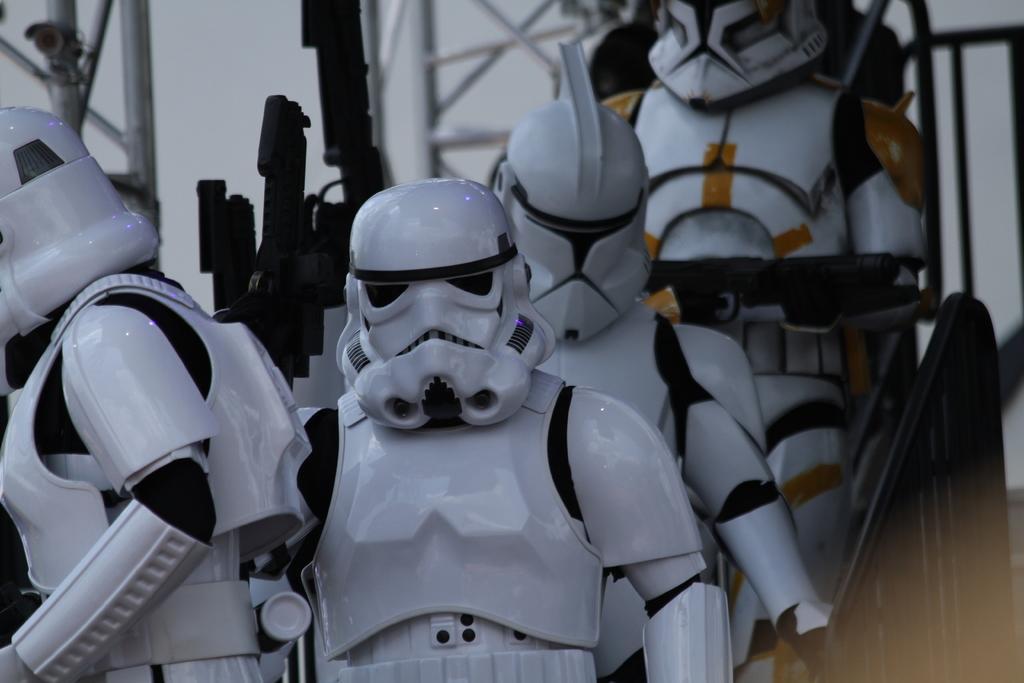In one or two sentences, can you explain what this image depicts? In this image we can see robots. There is a railing. In the background of the image there are rods. 